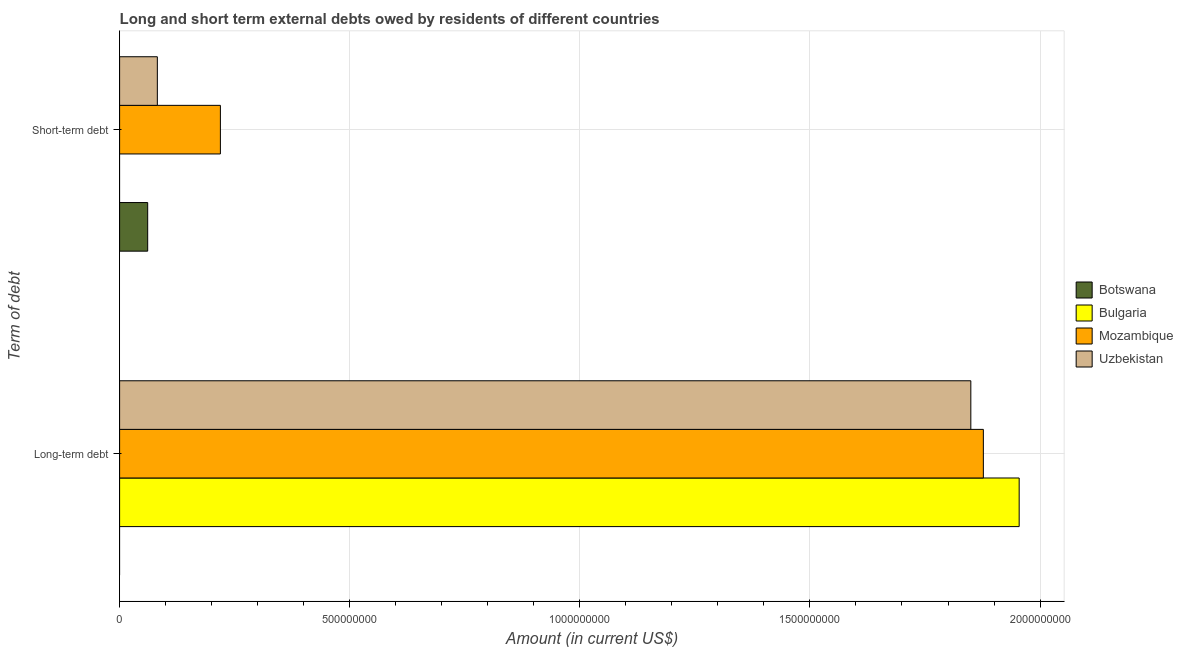How many different coloured bars are there?
Give a very brief answer. 4. Are the number of bars per tick equal to the number of legend labels?
Offer a very short reply. No. Are the number of bars on each tick of the Y-axis equal?
Offer a very short reply. Yes. How many bars are there on the 2nd tick from the bottom?
Ensure brevity in your answer.  3. What is the label of the 1st group of bars from the top?
Offer a very short reply. Short-term debt. What is the long-term debts owed by residents in Bulgaria?
Your answer should be compact. 1.95e+09. Across all countries, what is the maximum long-term debts owed by residents?
Your response must be concise. 1.95e+09. In which country was the long-term debts owed by residents maximum?
Your response must be concise. Bulgaria. What is the total short-term debts owed by residents in the graph?
Offer a very short reply. 3.62e+08. What is the difference between the long-term debts owed by residents in Bulgaria and that in Uzbekistan?
Offer a terse response. 1.05e+08. What is the difference between the long-term debts owed by residents in Uzbekistan and the short-term debts owed by residents in Botswana?
Provide a short and direct response. 1.79e+09. What is the average long-term debts owed by residents per country?
Give a very brief answer. 1.42e+09. What is the difference between the short-term debts owed by residents and long-term debts owed by residents in Mozambique?
Offer a terse response. -1.66e+09. What is the ratio of the short-term debts owed by residents in Botswana to that in Mozambique?
Keep it short and to the point. 0.28. How many bars are there?
Make the answer very short. 6. Are all the bars in the graph horizontal?
Your answer should be very brief. Yes. What is the difference between two consecutive major ticks on the X-axis?
Provide a short and direct response. 5.00e+08. Where does the legend appear in the graph?
Offer a terse response. Center right. How many legend labels are there?
Ensure brevity in your answer.  4. What is the title of the graph?
Give a very brief answer. Long and short term external debts owed by residents of different countries. What is the label or title of the Y-axis?
Offer a terse response. Term of debt. What is the Amount (in current US$) in Bulgaria in Long-term debt?
Provide a succinct answer. 1.95e+09. What is the Amount (in current US$) in Mozambique in Long-term debt?
Your answer should be compact. 1.88e+09. What is the Amount (in current US$) in Uzbekistan in Long-term debt?
Offer a terse response. 1.85e+09. What is the Amount (in current US$) in Botswana in Short-term debt?
Your response must be concise. 6.10e+07. What is the Amount (in current US$) in Mozambique in Short-term debt?
Give a very brief answer. 2.19e+08. What is the Amount (in current US$) in Uzbekistan in Short-term debt?
Provide a succinct answer. 8.20e+07. Across all Term of debt, what is the maximum Amount (in current US$) of Botswana?
Make the answer very short. 6.10e+07. Across all Term of debt, what is the maximum Amount (in current US$) in Bulgaria?
Keep it short and to the point. 1.95e+09. Across all Term of debt, what is the maximum Amount (in current US$) in Mozambique?
Ensure brevity in your answer.  1.88e+09. Across all Term of debt, what is the maximum Amount (in current US$) of Uzbekistan?
Provide a short and direct response. 1.85e+09. Across all Term of debt, what is the minimum Amount (in current US$) in Bulgaria?
Your answer should be very brief. 0. Across all Term of debt, what is the minimum Amount (in current US$) of Mozambique?
Give a very brief answer. 2.19e+08. Across all Term of debt, what is the minimum Amount (in current US$) of Uzbekistan?
Your answer should be compact. 8.20e+07. What is the total Amount (in current US$) of Botswana in the graph?
Your answer should be compact. 6.10e+07. What is the total Amount (in current US$) of Bulgaria in the graph?
Provide a short and direct response. 1.95e+09. What is the total Amount (in current US$) in Mozambique in the graph?
Offer a very short reply. 2.10e+09. What is the total Amount (in current US$) in Uzbekistan in the graph?
Keep it short and to the point. 1.93e+09. What is the difference between the Amount (in current US$) of Mozambique in Long-term debt and that in Short-term debt?
Give a very brief answer. 1.66e+09. What is the difference between the Amount (in current US$) of Uzbekistan in Long-term debt and that in Short-term debt?
Offer a terse response. 1.77e+09. What is the difference between the Amount (in current US$) in Bulgaria in Long-term debt and the Amount (in current US$) in Mozambique in Short-term debt?
Offer a terse response. 1.74e+09. What is the difference between the Amount (in current US$) of Bulgaria in Long-term debt and the Amount (in current US$) of Uzbekistan in Short-term debt?
Give a very brief answer. 1.87e+09. What is the difference between the Amount (in current US$) of Mozambique in Long-term debt and the Amount (in current US$) of Uzbekistan in Short-term debt?
Your answer should be very brief. 1.79e+09. What is the average Amount (in current US$) in Botswana per Term of debt?
Provide a succinct answer. 3.05e+07. What is the average Amount (in current US$) in Bulgaria per Term of debt?
Your response must be concise. 9.77e+08. What is the average Amount (in current US$) in Mozambique per Term of debt?
Your answer should be compact. 1.05e+09. What is the average Amount (in current US$) in Uzbekistan per Term of debt?
Ensure brevity in your answer.  9.66e+08. What is the difference between the Amount (in current US$) of Bulgaria and Amount (in current US$) of Mozambique in Long-term debt?
Offer a very short reply. 7.78e+07. What is the difference between the Amount (in current US$) of Bulgaria and Amount (in current US$) of Uzbekistan in Long-term debt?
Your answer should be compact. 1.05e+08. What is the difference between the Amount (in current US$) of Mozambique and Amount (in current US$) of Uzbekistan in Long-term debt?
Keep it short and to the point. 2.72e+07. What is the difference between the Amount (in current US$) in Botswana and Amount (in current US$) in Mozambique in Short-term debt?
Give a very brief answer. -1.58e+08. What is the difference between the Amount (in current US$) of Botswana and Amount (in current US$) of Uzbekistan in Short-term debt?
Your answer should be compact. -2.10e+07. What is the difference between the Amount (in current US$) of Mozambique and Amount (in current US$) of Uzbekistan in Short-term debt?
Offer a very short reply. 1.37e+08. What is the ratio of the Amount (in current US$) of Mozambique in Long-term debt to that in Short-term debt?
Your answer should be very brief. 8.57. What is the ratio of the Amount (in current US$) of Uzbekistan in Long-term debt to that in Short-term debt?
Your response must be concise. 22.56. What is the difference between the highest and the second highest Amount (in current US$) of Mozambique?
Your response must be concise. 1.66e+09. What is the difference between the highest and the second highest Amount (in current US$) in Uzbekistan?
Give a very brief answer. 1.77e+09. What is the difference between the highest and the lowest Amount (in current US$) in Botswana?
Your answer should be compact. 6.10e+07. What is the difference between the highest and the lowest Amount (in current US$) of Bulgaria?
Ensure brevity in your answer.  1.95e+09. What is the difference between the highest and the lowest Amount (in current US$) of Mozambique?
Make the answer very short. 1.66e+09. What is the difference between the highest and the lowest Amount (in current US$) of Uzbekistan?
Ensure brevity in your answer.  1.77e+09. 